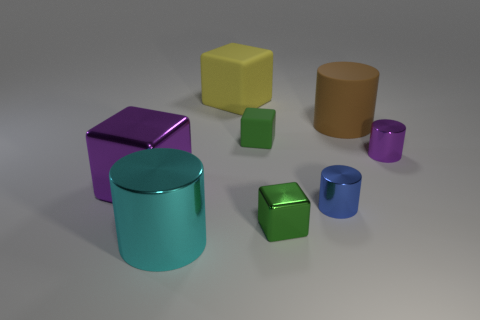What materials do the objects in the image appear to be made of? The objects in the image seem to have a metallic finish, suggesting that they could be made of metal or rendered with a metallic texture in a 3D program. 